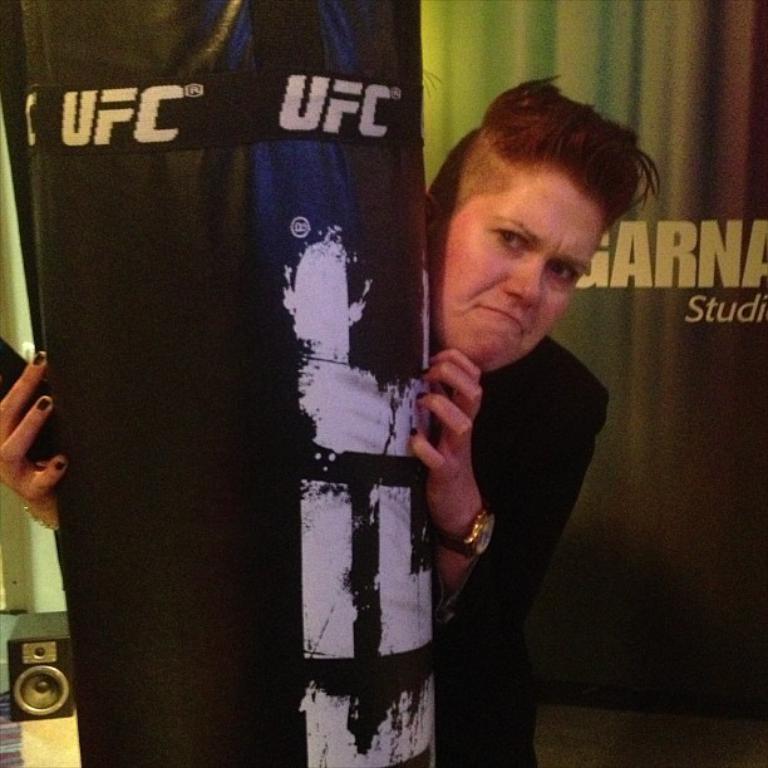What professional sporting association is advertised?
Your answer should be very brief. Ufc. What are all the alphabetical letters written behind the head?
Ensure brevity in your answer.  Garna. 